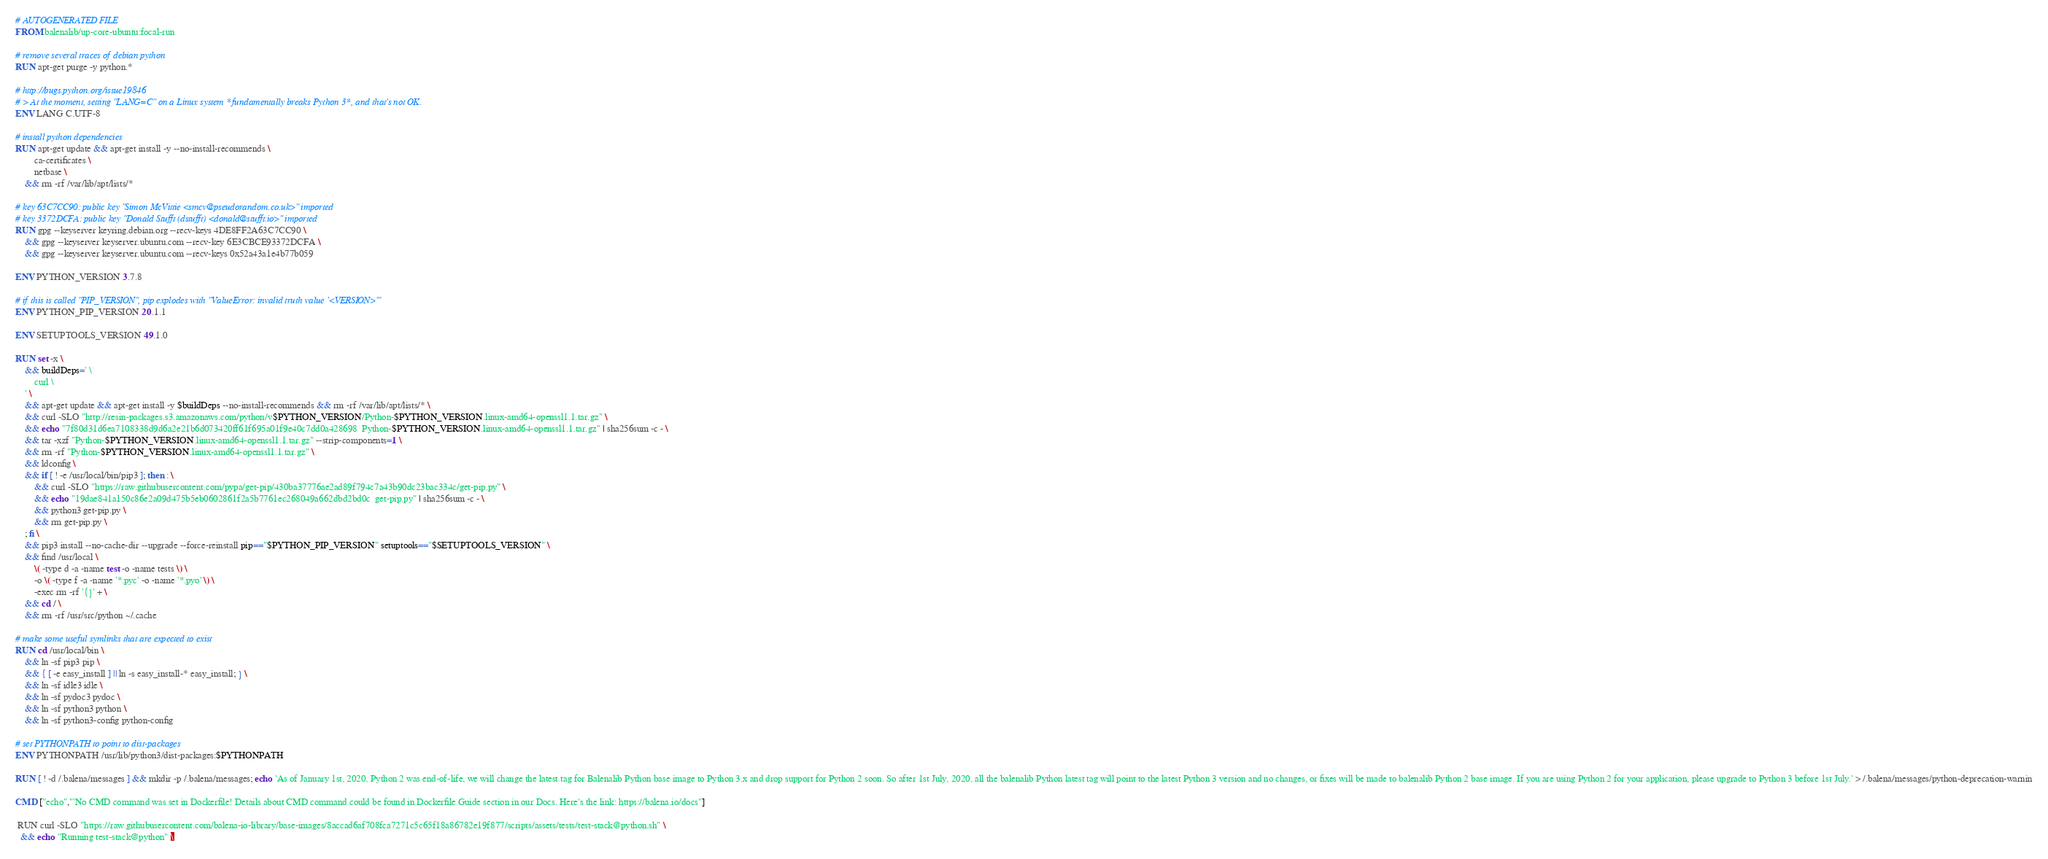<code> <loc_0><loc_0><loc_500><loc_500><_Dockerfile_># AUTOGENERATED FILE
FROM balenalib/up-core-ubuntu:focal-run

# remove several traces of debian python
RUN apt-get purge -y python.*

# http://bugs.python.org/issue19846
# > At the moment, setting "LANG=C" on a Linux system *fundamentally breaks Python 3*, and that's not OK.
ENV LANG C.UTF-8

# install python dependencies
RUN apt-get update && apt-get install -y --no-install-recommends \
		ca-certificates \
		netbase \
	&& rm -rf /var/lib/apt/lists/*

# key 63C7CC90: public key "Simon McVittie <smcv@pseudorandom.co.uk>" imported
# key 3372DCFA: public key "Donald Stufft (dstufft) <donald@stufft.io>" imported
RUN gpg --keyserver keyring.debian.org --recv-keys 4DE8FF2A63C7CC90 \
	&& gpg --keyserver keyserver.ubuntu.com --recv-key 6E3CBCE93372DCFA \
	&& gpg --keyserver keyserver.ubuntu.com --recv-keys 0x52a43a1e4b77b059

ENV PYTHON_VERSION 3.7.8

# if this is called "PIP_VERSION", pip explodes with "ValueError: invalid truth value '<VERSION>'"
ENV PYTHON_PIP_VERSION 20.1.1

ENV SETUPTOOLS_VERSION 49.1.0

RUN set -x \
	&& buildDeps=' \
		curl \
	' \
	&& apt-get update && apt-get install -y $buildDeps --no-install-recommends && rm -rf /var/lib/apt/lists/* \
	&& curl -SLO "http://resin-packages.s3.amazonaws.com/python/v$PYTHON_VERSION/Python-$PYTHON_VERSION.linux-amd64-openssl1.1.tar.gz" \
	&& echo "7f80d31d6ea7108338d9d6a2e21b6d073420ff61f695a01f9e40c7dd0a428698  Python-$PYTHON_VERSION.linux-amd64-openssl1.1.tar.gz" | sha256sum -c - \
	&& tar -xzf "Python-$PYTHON_VERSION.linux-amd64-openssl1.1.tar.gz" --strip-components=1 \
	&& rm -rf "Python-$PYTHON_VERSION.linux-amd64-openssl1.1.tar.gz" \
	&& ldconfig \
	&& if [ ! -e /usr/local/bin/pip3 ]; then : \
		&& curl -SLO "https://raw.githubusercontent.com/pypa/get-pip/430ba37776ae2ad89f794c7a43b90dc23bac334c/get-pip.py" \
		&& echo "19dae841a150c86e2a09d475b5eb0602861f2a5b7761ec268049a662dbd2bd0c  get-pip.py" | sha256sum -c - \
		&& python3 get-pip.py \
		&& rm get-pip.py \
	; fi \
	&& pip3 install --no-cache-dir --upgrade --force-reinstall pip=="$PYTHON_PIP_VERSION" setuptools=="$SETUPTOOLS_VERSION" \
	&& find /usr/local \
		\( -type d -a -name test -o -name tests \) \
		-o \( -type f -a -name '*.pyc' -o -name '*.pyo' \) \
		-exec rm -rf '{}' + \
	&& cd / \
	&& rm -rf /usr/src/python ~/.cache

# make some useful symlinks that are expected to exist
RUN cd /usr/local/bin \
	&& ln -sf pip3 pip \
	&& { [ -e easy_install ] || ln -s easy_install-* easy_install; } \
	&& ln -sf idle3 idle \
	&& ln -sf pydoc3 pydoc \
	&& ln -sf python3 python \
	&& ln -sf python3-config python-config

# set PYTHONPATH to point to dist-packages
ENV PYTHONPATH /usr/lib/python3/dist-packages:$PYTHONPATH

RUN [ ! -d /.balena/messages ] && mkdir -p /.balena/messages; echo 'As of January 1st, 2020, Python 2 was end-of-life, we will change the latest tag for Balenalib Python base image to Python 3.x and drop support for Python 2 soon. So after 1st July, 2020, all the balenalib Python latest tag will point to the latest Python 3 version and no changes, or fixes will be made to balenalib Python 2 base image. If you are using Python 2 for your application, please upgrade to Python 3 before 1st July.' > /.balena/messages/python-deprecation-warnin

CMD ["echo","'No CMD command was set in Dockerfile! Details about CMD command could be found in Dockerfile Guide section in our Docs. Here's the link: https://balena.io/docs"]

 RUN curl -SLO "https://raw.githubusercontent.com/balena-io-library/base-images/8accad6af708fca7271c5c65f18a86782e19f877/scripts/assets/tests/test-stack@python.sh" \
  && echo "Running test-stack@python" \</code> 